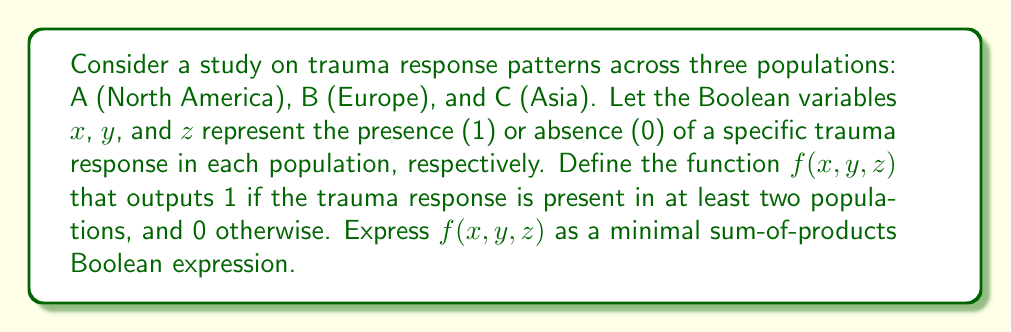Can you solve this math problem? To solve this problem, we'll follow these steps:

1) First, let's create a truth table for the function $f(x,y,z)$:

   $x$ | $y$ | $z$ | $f(x,y,z)$
   ----+-----+-----+-----------
   0   | 0   | 0   |    0
   0   | 0   | 1   |    0
   0   | 1   | 0   |    0
   0   | 1   | 1   |    1
   1   | 0   | 0   |    0
   1   | 0   | 1   |    1
   1   | 1   | 0   |    1
   1   | 1   | 1   |    1

2) We need to identify the minterms (input combinations) where $f(x,y,z) = 1$:

   $m_3 = x'yz$
   $m_5 = xy'z$
   $m_6 = xyz'$
   $m_7 = xyz$

3) The sum-of-products expression is the OR of these minterms:

   $f(x,y,z) = x'yz + xy'z + xyz' + xyz$

4) To minimize this expression, we can use the QuineMcCluskey algorithm or Karnaugh maps. Here, we can see that:

   $xy'z + xyz = xz(y' + y) = xz$
   $x'yz + xyz = yz(x' + x) = yz$
   $xyz' + xyz = xy(z' + z) = xy$

5) Therefore, the minimal sum-of-products expression is:

   $f(x,y,z) = xy + yz + xz$

This Boolean function represents the presence of the trauma response in at least two populations, which is relevant to analyzing trauma response patterns across different cultural contexts.
Answer: $f(x,y,z) = xy + yz + xz$ 